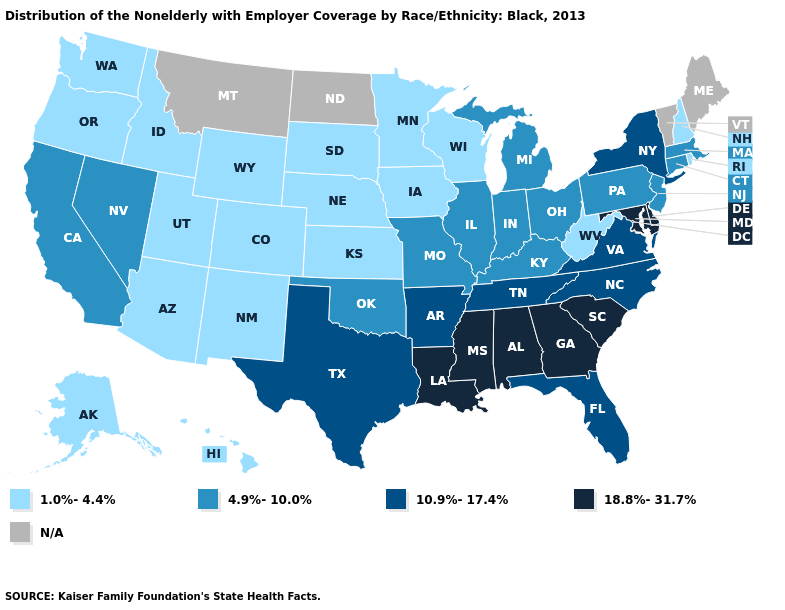Does South Dakota have the highest value in the MidWest?
Give a very brief answer. No. Name the states that have a value in the range 10.9%-17.4%?
Be succinct. Arkansas, Florida, New York, North Carolina, Tennessee, Texas, Virginia. What is the value of Arizona?
Be succinct. 1.0%-4.4%. Name the states that have a value in the range 1.0%-4.4%?
Concise answer only. Alaska, Arizona, Colorado, Hawaii, Idaho, Iowa, Kansas, Minnesota, Nebraska, New Hampshire, New Mexico, Oregon, Rhode Island, South Dakota, Utah, Washington, West Virginia, Wisconsin, Wyoming. Name the states that have a value in the range N/A?
Be succinct. Maine, Montana, North Dakota, Vermont. Which states have the lowest value in the MidWest?
Write a very short answer. Iowa, Kansas, Minnesota, Nebraska, South Dakota, Wisconsin. Name the states that have a value in the range 18.8%-31.7%?
Give a very brief answer. Alabama, Delaware, Georgia, Louisiana, Maryland, Mississippi, South Carolina. Does the map have missing data?
Keep it brief. Yes. Does Kansas have the highest value in the MidWest?
Keep it brief. No. Does California have the lowest value in the West?
Concise answer only. No. What is the value of West Virginia?
Concise answer only. 1.0%-4.4%. What is the value of Minnesota?
Short answer required. 1.0%-4.4%. Name the states that have a value in the range 10.9%-17.4%?
Give a very brief answer. Arkansas, Florida, New York, North Carolina, Tennessee, Texas, Virginia. Name the states that have a value in the range 4.9%-10.0%?
Write a very short answer. California, Connecticut, Illinois, Indiana, Kentucky, Massachusetts, Michigan, Missouri, Nevada, New Jersey, Ohio, Oklahoma, Pennsylvania. What is the highest value in the MidWest ?
Give a very brief answer. 4.9%-10.0%. 